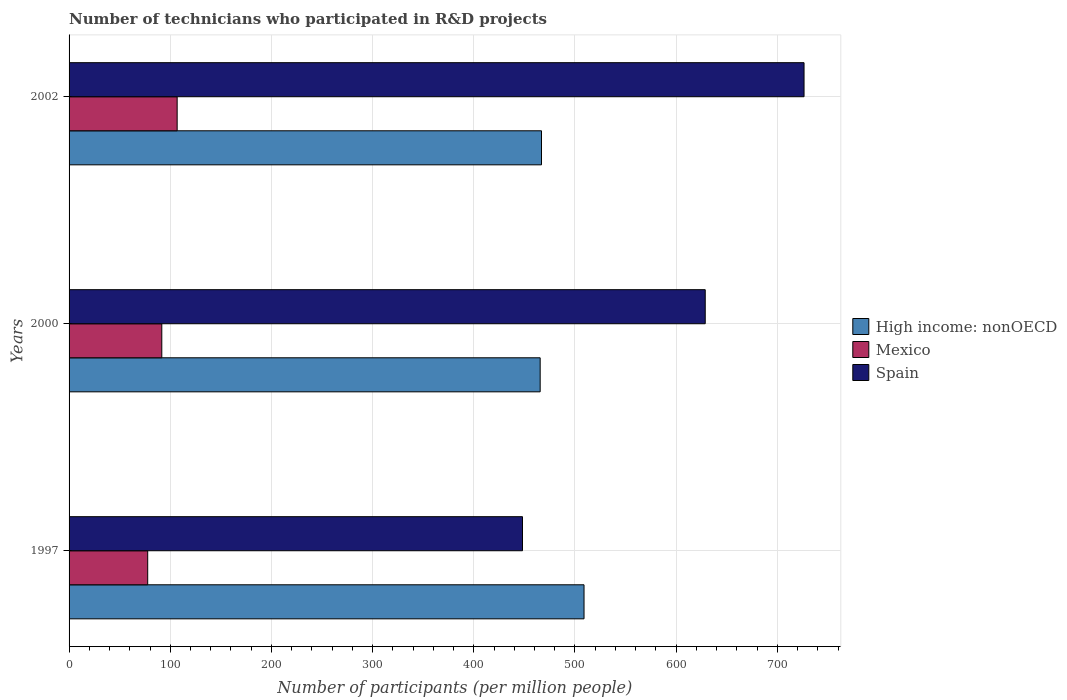How many groups of bars are there?
Your answer should be very brief. 3. Are the number of bars per tick equal to the number of legend labels?
Make the answer very short. Yes. Are the number of bars on each tick of the Y-axis equal?
Keep it short and to the point. Yes. What is the label of the 1st group of bars from the top?
Make the answer very short. 2002. In how many cases, is the number of bars for a given year not equal to the number of legend labels?
Ensure brevity in your answer.  0. What is the number of technicians who participated in R&D projects in Spain in 1997?
Ensure brevity in your answer.  448.17. Across all years, what is the maximum number of technicians who participated in R&D projects in Spain?
Your answer should be compact. 726.43. Across all years, what is the minimum number of technicians who participated in R&D projects in High income: nonOECD?
Provide a short and direct response. 465.64. In which year was the number of technicians who participated in R&D projects in Mexico minimum?
Your answer should be compact. 1997. What is the total number of technicians who participated in R&D projects in Mexico in the graph?
Provide a succinct answer. 276.2. What is the difference between the number of technicians who participated in R&D projects in Mexico in 1997 and that in 2002?
Your answer should be very brief. -29.11. What is the difference between the number of technicians who participated in R&D projects in Spain in 2000 and the number of technicians who participated in R&D projects in High income: nonOECD in 2002?
Offer a very short reply. 161.83. What is the average number of technicians who participated in R&D projects in High income: nonOECD per year?
Your answer should be compact. 480.52. In the year 2000, what is the difference between the number of technicians who participated in R&D projects in Mexico and number of technicians who participated in R&D projects in High income: nonOECD?
Your answer should be very brief. -373.99. In how many years, is the number of technicians who participated in R&D projects in High income: nonOECD greater than 320 ?
Ensure brevity in your answer.  3. What is the ratio of the number of technicians who participated in R&D projects in Spain in 2000 to that in 2002?
Offer a terse response. 0.87. Is the number of technicians who participated in R&D projects in Mexico in 1997 less than that in 2000?
Provide a succinct answer. Yes. Is the difference between the number of technicians who participated in R&D projects in Mexico in 1997 and 2002 greater than the difference between the number of technicians who participated in R&D projects in High income: nonOECD in 1997 and 2002?
Ensure brevity in your answer.  No. What is the difference between the highest and the second highest number of technicians who participated in R&D projects in Spain?
Ensure brevity in your answer.  97.66. What is the difference between the highest and the lowest number of technicians who participated in R&D projects in Mexico?
Give a very brief answer. 29.11. In how many years, is the number of technicians who participated in R&D projects in Mexico greater than the average number of technicians who participated in R&D projects in Mexico taken over all years?
Keep it short and to the point. 1. Is the sum of the number of technicians who participated in R&D projects in Spain in 1997 and 2002 greater than the maximum number of technicians who participated in R&D projects in Mexico across all years?
Your answer should be very brief. Yes. What does the 3rd bar from the top in 2000 represents?
Keep it short and to the point. High income: nonOECD. Are all the bars in the graph horizontal?
Keep it short and to the point. Yes. How many years are there in the graph?
Your answer should be very brief. 3. Are the values on the major ticks of X-axis written in scientific E-notation?
Ensure brevity in your answer.  No. Does the graph contain grids?
Offer a terse response. Yes. How many legend labels are there?
Provide a succinct answer. 3. How are the legend labels stacked?
Give a very brief answer. Vertical. What is the title of the graph?
Your answer should be compact. Number of technicians who participated in R&D projects. What is the label or title of the X-axis?
Offer a terse response. Number of participants (per million people). What is the label or title of the Y-axis?
Offer a terse response. Years. What is the Number of participants (per million people) in High income: nonOECD in 1997?
Provide a short and direct response. 508.98. What is the Number of participants (per million people) in Mexico in 1997?
Provide a succinct answer. 77.72. What is the Number of participants (per million people) in Spain in 1997?
Your answer should be very brief. 448.17. What is the Number of participants (per million people) of High income: nonOECD in 2000?
Provide a short and direct response. 465.64. What is the Number of participants (per million people) of Mexico in 2000?
Your response must be concise. 91.65. What is the Number of participants (per million people) in Spain in 2000?
Your answer should be compact. 628.77. What is the Number of participants (per million people) in High income: nonOECD in 2002?
Make the answer very short. 466.95. What is the Number of participants (per million people) of Mexico in 2002?
Provide a short and direct response. 106.83. What is the Number of participants (per million people) of Spain in 2002?
Your answer should be compact. 726.43. Across all years, what is the maximum Number of participants (per million people) in High income: nonOECD?
Offer a very short reply. 508.98. Across all years, what is the maximum Number of participants (per million people) of Mexico?
Your answer should be very brief. 106.83. Across all years, what is the maximum Number of participants (per million people) of Spain?
Make the answer very short. 726.43. Across all years, what is the minimum Number of participants (per million people) of High income: nonOECD?
Offer a very short reply. 465.64. Across all years, what is the minimum Number of participants (per million people) in Mexico?
Your answer should be compact. 77.72. Across all years, what is the minimum Number of participants (per million people) of Spain?
Keep it short and to the point. 448.17. What is the total Number of participants (per million people) of High income: nonOECD in the graph?
Your answer should be compact. 1441.57. What is the total Number of participants (per million people) in Mexico in the graph?
Give a very brief answer. 276.2. What is the total Number of participants (per million people) in Spain in the graph?
Keep it short and to the point. 1803.38. What is the difference between the Number of participants (per million people) of High income: nonOECD in 1997 and that in 2000?
Offer a very short reply. 43.35. What is the difference between the Number of participants (per million people) in Mexico in 1997 and that in 2000?
Ensure brevity in your answer.  -13.92. What is the difference between the Number of participants (per million people) of Spain in 1997 and that in 2000?
Provide a short and direct response. -180.61. What is the difference between the Number of participants (per million people) in High income: nonOECD in 1997 and that in 2002?
Make the answer very short. 42.03. What is the difference between the Number of participants (per million people) of Mexico in 1997 and that in 2002?
Your answer should be compact. -29.11. What is the difference between the Number of participants (per million people) in Spain in 1997 and that in 2002?
Your response must be concise. -278.27. What is the difference between the Number of participants (per million people) of High income: nonOECD in 2000 and that in 2002?
Make the answer very short. -1.31. What is the difference between the Number of participants (per million people) in Mexico in 2000 and that in 2002?
Offer a very short reply. -15.18. What is the difference between the Number of participants (per million people) of Spain in 2000 and that in 2002?
Your response must be concise. -97.66. What is the difference between the Number of participants (per million people) in High income: nonOECD in 1997 and the Number of participants (per million people) in Mexico in 2000?
Your response must be concise. 417.34. What is the difference between the Number of participants (per million people) in High income: nonOECD in 1997 and the Number of participants (per million people) in Spain in 2000?
Offer a very short reply. -119.79. What is the difference between the Number of participants (per million people) in Mexico in 1997 and the Number of participants (per million people) in Spain in 2000?
Keep it short and to the point. -551.05. What is the difference between the Number of participants (per million people) of High income: nonOECD in 1997 and the Number of participants (per million people) of Mexico in 2002?
Your response must be concise. 402.15. What is the difference between the Number of participants (per million people) in High income: nonOECD in 1997 and the Number of participants (per million people) in Spain in 2002?
Offer a terse response. -217.45. What is the difference between the Number of participants (per million people) in Mexico in 1997 and the Number of participants (per million people) in Spain in 2002?
Make the answer very short. -648.71. What is the difference between the Number of participants (per million people) of High income: nonOECD in 2000 and the Number of participants (per million people) of Mexico in 2002?
Make the answer very short. 358.81. What is the difference between the Number of participants (per million people) of High income: nonOECD in 2000 and the Number of participants (per million people) of Spain in 2002?
Your answer should be very brief. -260.8. What is the difference between the Number of participants (per million people) in Mexico in 2000 and the Number of participants (per million people) in Spain in 2002?
Ensure brevity in your answer.  -634.79. What is the average Number of participants (per million people) of High income: nonOECD per year?
Offer a terse response. 480.52. What is the average Number of participants (per million people) of Mexico per year?
Give a very brief answer. 92.07. What is the average Number of participants (per million people) in Spain per year?
Keep it short and to the point. 601.13. In the year 1997, what is the difference between the Number of participants (per million people) of High income: nonOECD and Number of participants (per million people) of Mexico?
Offer a terse response. 431.26. In the year 1997, what is the difference between the Number of participants (per million people) of High income: nonOECD and Number of participants (per million people) of Spain?
Your response must be concise. 60.81. In the year 1997, what is the difference between the Number of participants (per million people) in Mexico and Number of participants (per million people) in Spain?
Your response must be concise. -370.45. In the year 2000, what is the difference between the Number of participants (per million people) in High income: nonOECD and Number of participants (per million people) in Mexico?
Offer a terse response. 373.99. In the year 2000, what is the difference between the Number of participants (per million people) in High income: nonOECD and Number of participants (per million people) in Spain?
Your answer should be very brief. -163.14. In the year 2000, what is the difference between the Number of participants (per million people) in Mexico and Number of participants (per million people) in Spain?
Offer a very short reply. -537.13. In the year 2002, what is the difference between the Number of participants (per million people) of High income: nonOECD and Number of participants (per million people) of Mexico?
Ensure brevity in your answer.  360.12. In the year 2002, what is the difference between the Number of participants (per million people) of High income: nonOECD and Number of participants (per million people) of Spain?
Your answer should be very brief. -259.49. In the year 2002, what is the difference between the Number of participants (per million people) in Mexico and Number of participants (per million people) in Spain?
Provide a succinct answer. -619.6. What is the ratio of the Number of participants (per million people) in High income: nonOECD in 1997 to that in 2000?
Ensure brevity in your answer.  1.09. What is the ratio of the Number of participants (per million people) of Mexico in 1997 to that in 2000?
Ensure brevity in your answer.  0.85. What is the ratio of the Number of participants (per million people) in Spain in 1997 to that in 2000?
Give a very brief answer. 0.71. What is the ratio of the Number of participants (per million people) of High income: nonOECD in 1997 to that in 2002?
Provide a short and direct response. 1.09. What is the ratio of the Number of participants (per million people) in Mexico in 1997 to that in 2002?
Make the answer very short. 0.73. What is the ratio of the Number of participants (per million people) of Spain in 1997 to that in 2002?
Ensure brevity in your answer.  0.62. What is the ratio of the Number of participants (per million people) of Mexico in 2000 to that in 2002?
Give a very brief answer. 0.86. What is the ratio of the Number of participants (per million people) in Spain in 2000 to that in 2002?
Ensure brevity in your answer.  0.87. What is the difference between the highest and the second highest Number of participants (per million people) of High income: nonOECD?
Offer a terse response. 42.03. What is the difference between the highest and the second highest Number of participants (per million people) in Mexico?
Offer a very short reply. 15.18. What is the difference between the highest and the second highest Number of participants (per million people) of Spain?
Give a very brief answer. 97.66. What is the difference between the highest and the lowest Number of participants (per million people) of High income: nonOECD?
Offer a terse response. 43.35. What is the difference between the highest and the lowest Number of participants (per million people) in Mexico?
Ensure brevity in your answer.  29.11. What is the difference between the highest and the lowest Number of participants (per million people) of Spain?
Offer a terse response. 278.27. 